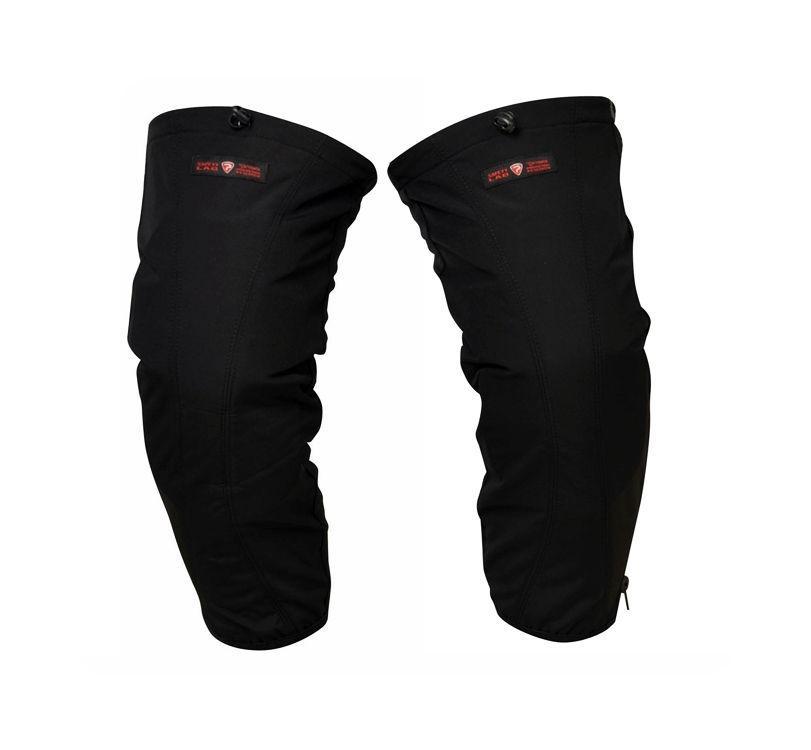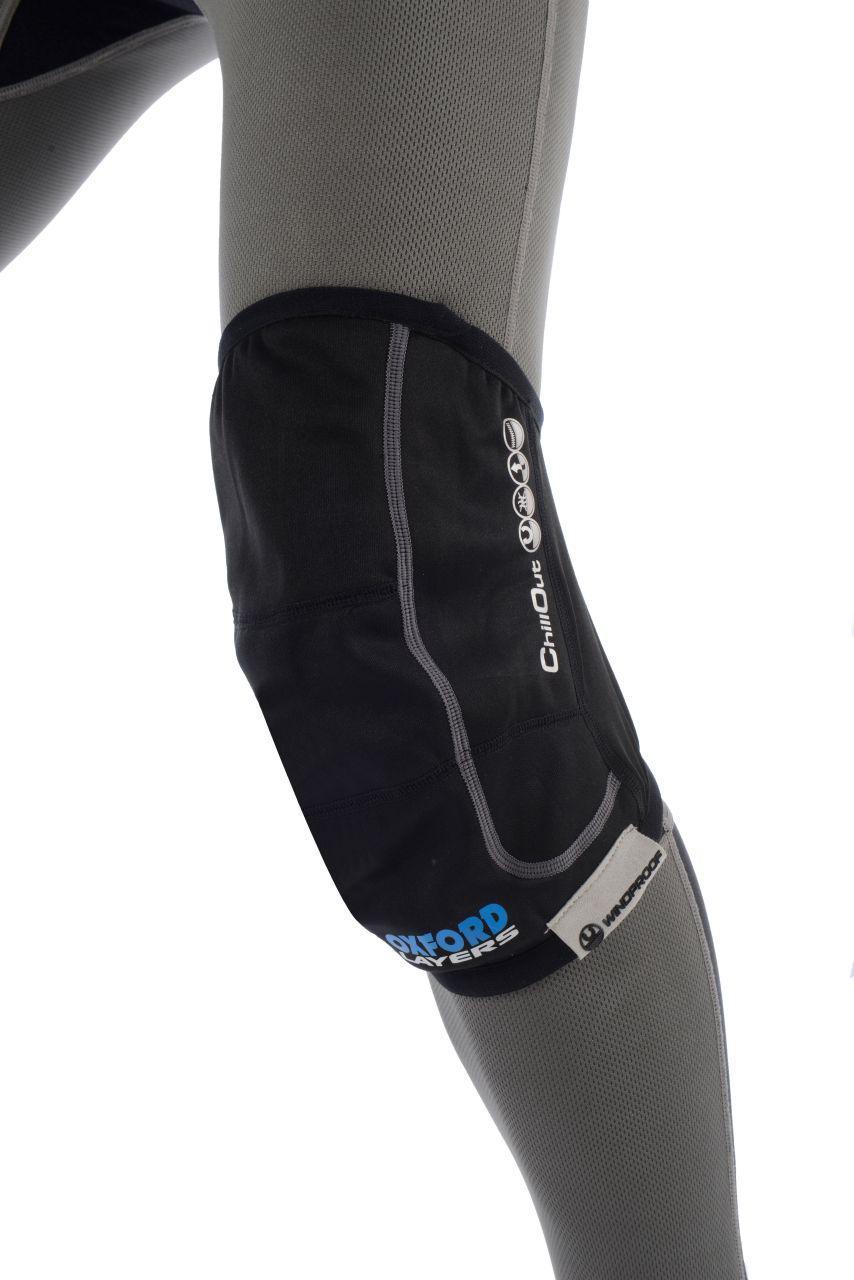The first image is the image on the left, the second image is the image on the right. For the images shown, is this caption "Each image includes at least one human leg with exposed skin, and each human leg wears a knee wrap." true? Answer yes or no. No. The first image is the image on the left, the second image is the image on the right. Analyze the images presented: Is the assertion "The left and right image each have at least on all black knee pads minus the labeling." valid? Answer yes or no. Yes. 